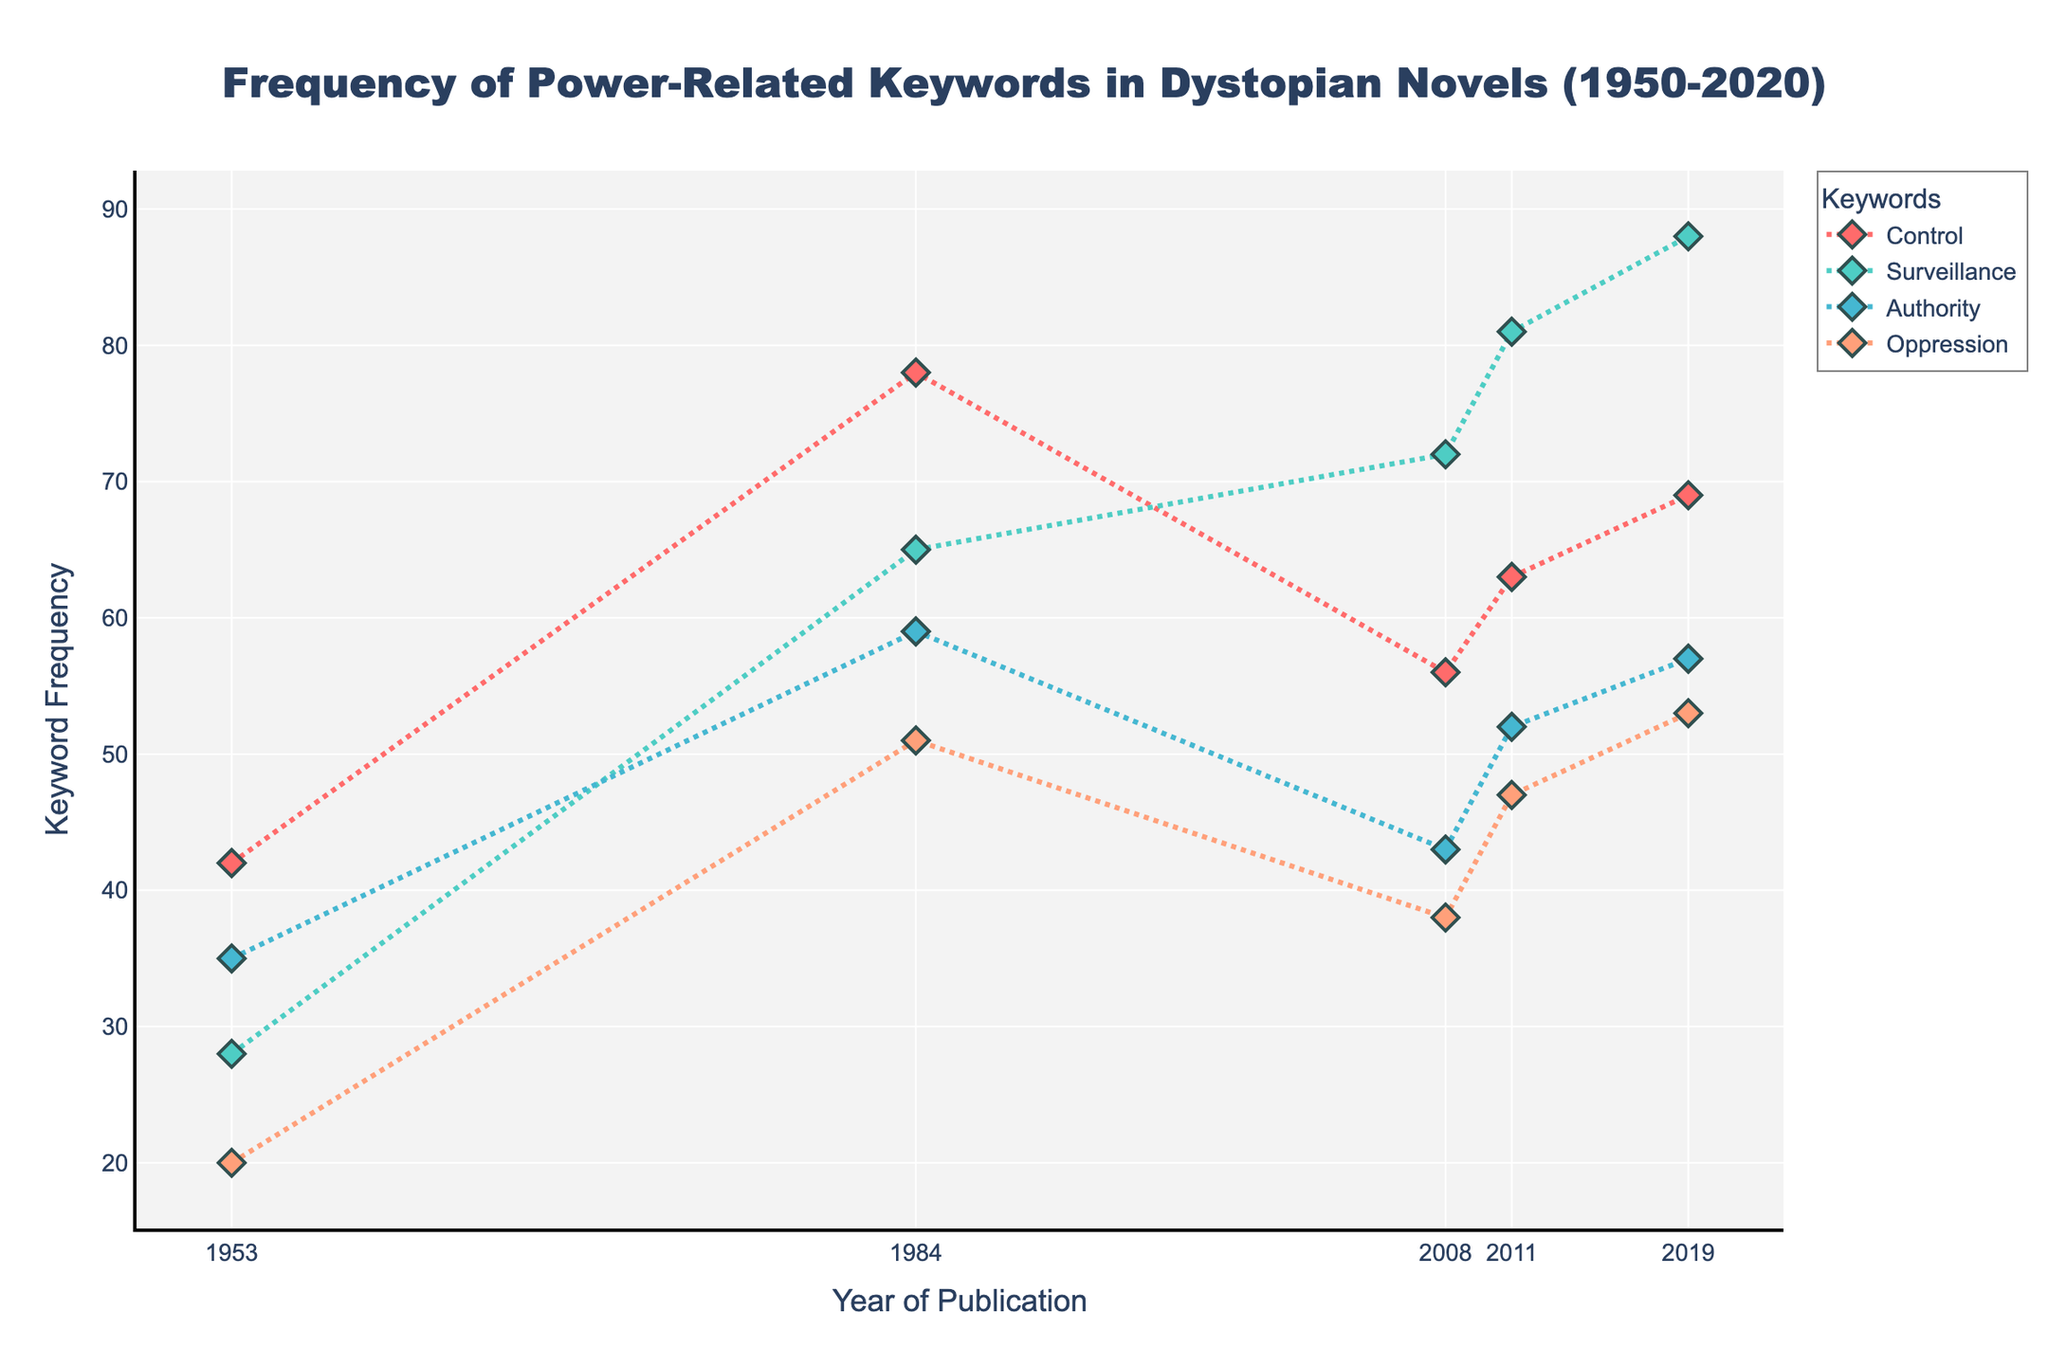How many keywords are shown in the plot? To determine the number of keywords, look at the legend of the plot which lists each keyword. Here, four keywords are displayed: Control, Surveillance, Authority, and Oppression.
Answer: 4 What is the overall trend for the keyword 'Surveillance' between 1953 and 2019? To determine the trend, plot the frequencies for 'Surveillance' across all years. The values are 28 in 1953, 65 in 1984, 72 in 2008, 81 in 2011, and 88 in 2019. There is a clear upward trend over time.
Answer: Increasing Which keyword shows the highest frequency in the year 1984? To find the highest frequency, compare the values of all keywords in 1984: Control (78), Surveillance (65), Authority (59), and Oppression (51). The keyword 'Control' has the highest value of 78.
Answer: Control What is the total frequency of the keyword 'Control' across all recorded years? To find the total frequency, sum up the values for 'Control': 42 (1953) + 78 (1984) + 56 (2008) + 63 (2011) + 69 (2019) = 308.
Answer: 308 Which keyword had the smallest increase in frequency from 1953 to 2019? Calculate the increase for each keyword from 1953 to 2019 and find the smallest change: Control (69 - 42 = 27), Surveillance (88 - 28 = 60), Authority (57 - 35 = 22), and Oppression (53 - 20 = 33). Authority has the smallest increase.
Answer: Authority In what year was the frequency of 'Authority' highest? Compare the frequencies of 'Authority' across all years: 1953 (35), 1984 (59), 2008 (43), 2011 (52), and 2019 (57). The year 1984 has the highest frequency at 59.
Answer: 1984 Which keyword showed the greatest variability in its frequency over the recorded years? To determine variability, observe the range (difference between max and min values) for each keyword: Control (78 - 42 = 36), Surveillance (88 - 28 = 60), Authority (59 - 35 = 24), Oppression (53 - 20 = 33). Surveillance shows the greatest variability with a range of 60.
Answer: Surveillance During which period did 'Oppression' experience the largest single increase in frequency? To find the largest single increase, we compare the changes between subsequent years for 'Oppression': 1953 to 1984 (51 - 20 = 31), 1984 to 2008 (38 - 51 = -13), 2008 to 2011 (47 - 38 = 9), and 2011 to 2019 (53 - 47 = 6). The largest increase is from 1953 to 1984 with a difference of 31.
Answer: 1953-1984 